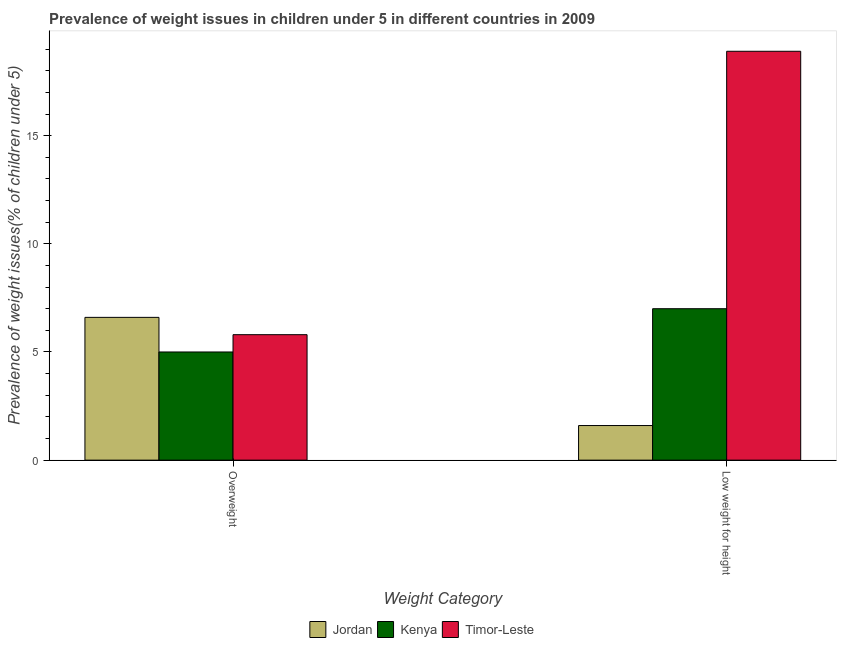Are the number of bars per tick equal to the number of legend labels?
Ensure brevity in your answer.  Yes. Are the number of bars on each tick of the X-axis equal?
Ensure brevity in your answer.  Yes. How many bars are there on the 2nd tick from the left?
Provide a short and direct response. 3. What is the label of the 1st group of bars from the left?
Offer a terse response. Overweight. What is the percentage of underweight children in Jordan?
Offer a very short reply. 1.6. Across all countries, what is the maximum percentage of underweight children?
Provide a succinct answer. 18.9. Across all countries, what is the minimum percentage of overweight children?
Your answer should be compact. 5. In which country was the percentage of overweight children maximum?
Give a very brief answer. Jordan. In which country was the percentage of overweight children minimum?
Give a very brief answer. Kenya. What is the total percentage of overweight children in the graph?
Make the answer very short. 17.4. What is the difference between the percentage of underweight children in Kenya and that in Timor-Leste?
Provide a succinct answer. -11.9. What is the difference between the percentage of overweight children in Kenya and the percentage of underweight children in Jordan?
Give a very brief answer. 3.4. What is the average percentage of underweight children per country?
Keep it short and to the point. 9.17. What is the difference between the percentage of underweight children and percentage of overweight children in Timor-Leste?
Offer a very short reply. 13.1. In how many countries, is the percentage of overweight children greater than 8 %?
Your answer should be very brief. 0. What is the ratio of the percentage of underweight children in Kenya to that in Jordan?
Your answer should be very brief. 4.37. In how many countries, is the percentage of underweight children greater than the average percentage of underweight children taken over all countries?
Your answer should be compact. 1. What does the 3rd bar from the left in Overweight represents?
Your answer should be compact. Timor-Leste. What does the 2nd bar from the right in Low weight for height represents?
Offer a very short reply. Kenya. How many countries are there in the graph?
Give a very brief answer. 3. What is the difference between two consecutive major ticks on the Y-axis?
Ensure brevity in your answer.  5. Where does the legend appear in the graph?
Give a very brief answer. Bottom center. How many legend labels are there?
Your answer should be very brief. 3. How are the legend labels stacked?
Keep it short and to the point. Horizontal. What is the title of the graph?
Keep it short and to the point. Prevalence of weight issues in children under 5 in different countries in 2009. What is the label or title of the X-axis?
Offer a very short reply. Weight Category. What is the label or title of the Y-axis?
Make the answer very short. Prevalence of weight issues(% of children under 5). What is the Prevalence of weight issues(% of children under 5) in Jordan in Overweight?
Make the answer very short. 6.6. What is the Prevalence of weight issues(% of children under 5) of Timor-Leste in Overweight?
Offer a very short reply. 5.8. What is the Prevalence of weight issues(% of children under 5) in Jordan in Low weight for height?
Provide a short and direct response. 1.6. What is the Prevalence of weight issues(% of children under 5) of Timor-Leste in Low weight for height?
Provide a short and direct response. 18.9. Across all Weight Category, what is the maximum Prevalence of weight issues(% of children under 5) in Jordan?
Ensure brevity in your answer.  6.6. Across all Weight Category, what is the maximum Prevalence of weight issues(% of children under 5) of Timor-Leste?
Offer a very short reply. 18.9. Across all Weight Category, what is the minimum Prevalence of weight issues(% of children under 5) in Jordan?
Offer a very short reply. 1.6. Across all Weight Category, what is the minimum Prevalence of weight issues(% of children under 5) in Timor-Leste?
Ensure brevity in your answer.  5.8. What is the total Prevalence of weight issues(% of children under 5) of Timor-Leste in the graph?
Give a very brief answer. 24.7. What is the difference between the Prevalence of weight issues(% of children under 5) in Jordan in Overweight and that in Low weight for height?
Your answer should be very brief. 5. What is the difference between the Prevalence of weight issues(% of children under 5) of Timor-Leste in Overweight and that in Low weight for height?
Offer a terse response. -13.1. What is the difference between the Prevalence of weight issues(% of children under 5) in Jordan in Overweight and the Prevalence of weight issues(% of children under 5) in Kenya in Low weight for height?
Give a very brief answer. -0.4. What is the difference between the Prevalence of weight issues(% of children under 5) of Kenya in Overweight and the Prevalence of weight issues(% of children under 5) of Timor-Leste in Low weight for height?
Ensure brevity in your answer.  -13.9. What is the average Prevalence of weight issues(% of children under 5) in Jordan per Weight Category?
Make the answer very short. 4.1. What is the average Prevalence of weight issues(% of children under 5) in Kenya per Weight Category?
Give a very brief answer. 6. What is the average Prevalence of weight issues(% of children under 5) of Timor-Leste per Weight Category?
Your answer should be compact. 12.35. What is the difference between the Prevalence of weight issues(% of children under 5) of Jordan and Prevalence of weight issues(% of children under 5) of Kenya in Overweight?
Your answer should be very brief. 1.6. What is the difference between the Prevalence of weight issues(% of children under 5) in Kenya and Prevalence of weight issues(% of children under 5) in Timor-Leste in Overweight?
Ensure brevity in your answer.  -0.8. What is the difference between the Prevalence of weight issues(% of children under 5) of Jordan and Prevalence of weight issues(% of children under 5) of Kenya in Low weight for height?
Your answer should be compact. -5.4. What is the difference between the Prevalence of weight issues(% of children under 5) of Jordan and Prevalence of weight issues(% of children under 5) of Timor-Leste in Low weight for height?
Keep it short and to the point. -17.3. What is the difference between the Prevalence of weight issues(% of children under 5) of Kenya and Prevalence of weight issues(% of children under 5) of Timor-Leste in Low weight for height?
Make the answer very short. -11.9. What is the ratio of the Prevalence of weight issues(% of children under 5) of Jordan in Overweight to that in Low weight for height?
Your answer should be compact. 4.12. What is the ratio of the Prevalence of weight issues(% of children under 5) of Kenya in Overweight to that in Low weight for height?
Ensure brevity in your answer.  0.71. What is the ratio of the Prevalence of weight issues(% of children under 5) of Timor-Leste in Overweight to that in Low weight for height?
Make the answer very short. 0.31. 